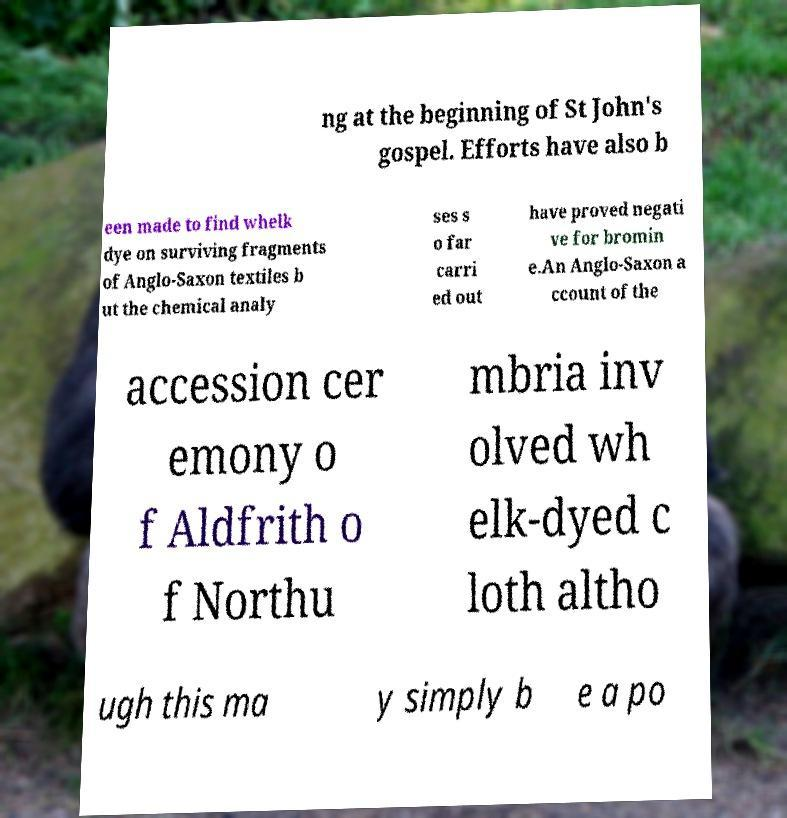Can you accurately transcribe the text from the provided image for me? ng at the beginning of St John's gospel. Efforts have also b een made to find whelk dye on surviving fragments of Anglo-Saxon textiles b ut the chemical analy ses s o far carri ed out have proved negati ve for bromin e.An Anglo-Saxon a ccount of the accession cer emony o f Aldfrith o f Northu mbria inv olved wh elk-dyed c loth altho ugh this ma y simply b e a po 